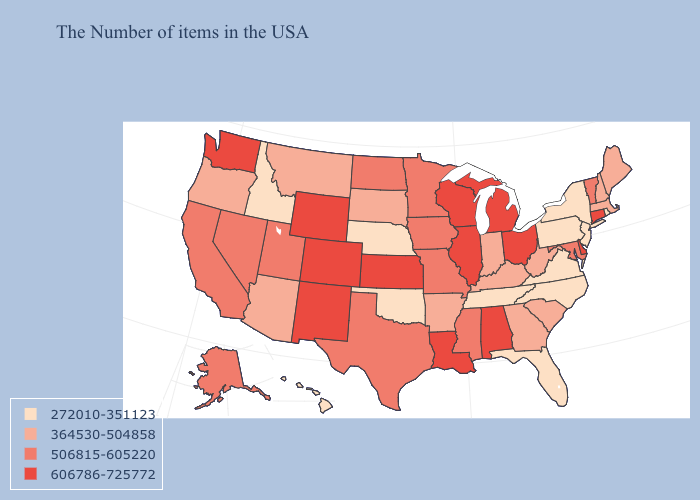What is the lowest value in states that border New Hampshire?
Answer briefly. 364530-504858. Name the states that have a value in the range 506815-605220?
Quick response, please. Vermont, Maryland, Mississippi, Missouri, Minnesota, Iowa, Texas, North Dakota, Utah, Nevada, California, Alaska. What is the value of New Mexico?
Concise answer only. 606786-725772. Does the first symbol in the legend represent the smallest category?
Quick response, please. Yes. Name the states that have a value in the range 606786-725772?
Concise answer only. Connecticut, Delaware, Ohio, Michigan, Alabama, Wisconsin, Illinois, Louisiana, Kansas, Wyoming, Colorado, New Mexico, Washington. Among the states that border South Carolina , does North Carolina have the lowest value?
Quick response, please. Yes. Does the map have missing data?
Short answer required. No. Which states have the highest value in the USA?
Give a very brief answer. Connecticut, Delaware, Ohio, Michigan, Alabama, Wisconsin, Illinois, Louisiana, Kansas, Wyoming, Colorado, New Mexico, Washington. Name the states that have a value in the range 364530-504858?
Answer briefly. Maine, Massachusetts, New Hampshire, South Carolina, West Virginia, Georgia, Kentucky, Indiana, Arkansas, South Dakota, Montana, Arizona, Oregon. Name the states that have a value in the range 506815-605220?
Be succinct. Vermont, Maryland, Mississippi, Missouri, Minnesota, Iowa, Texas, North Dakota, Utah, Nevada, California, Alaska. Name the states that have a value in the range 506815-605220?
Keep it brief. Vermont, Maryland, Mississippi, Missouri, Minnesota, Iowa, Texas, North Dakota, Utah, Nevada, California, Alaska. Name the states that have a value in the range 364530-504858?
Concise answer only. Maine, Massachusetts, New Hampshire, South Carolina, West Virginia, Georgia, Kentucky, Indiana, Arkansas, South Dakota, Montana, Arizona, Oregon. Among the states that border Delaware , does Pennsylvania have the highest value?
Write a very short answer. No. Does Kentucky have the lowest value in the South?
Answer briefly. No. Name the states that have a value in the range 606786-725772?
Be succinct. Connecticut, Delaware, Ohio, Michigan, Alabama, Wisconsin, Illinois, Louisiana, Kansas, Wyoming, Colorado, New Mexico, Washington. 